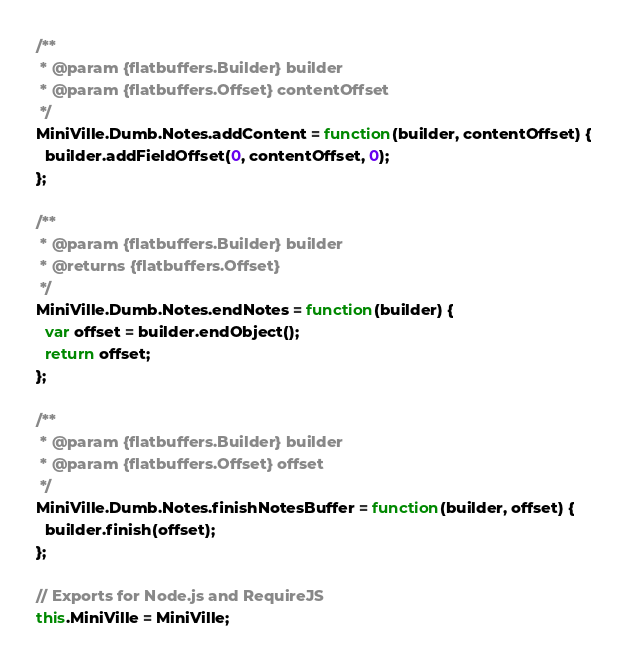Convert code to text. <code><loc_0><loc_0><loc_500><loc_500><_JavaScript_>/**
 * @param {flatbuffers.Builder} builder
 * @param {flatbuffers.Offset} contentOffset
 */
MiniVille.Dumb.Notes.addContent = function(builder, contentOffset) {
  builder.addFieldOffset(0, contentOffset, 0);
};

/**
 * @param {flatbuffers.Builder} builder
 * @returns {flatbuffers.Offset}
 */
MiniVille.Dumb.Notes.endNotes = function(builder) {
  var offset = builder.endObject();
  return offset;
};

/**
 * @param {flatbuffers.Builder} builder
 * @param {flatbuffers.Offset} offset
 */
MiniVille.Dumb.Notes.finishNotesBuffer = function(builder, offset) {
  builder.finish(offset);
};

// Exports for Node.js and RequireJS
this.MiniVille = MiniVille;
</code> 